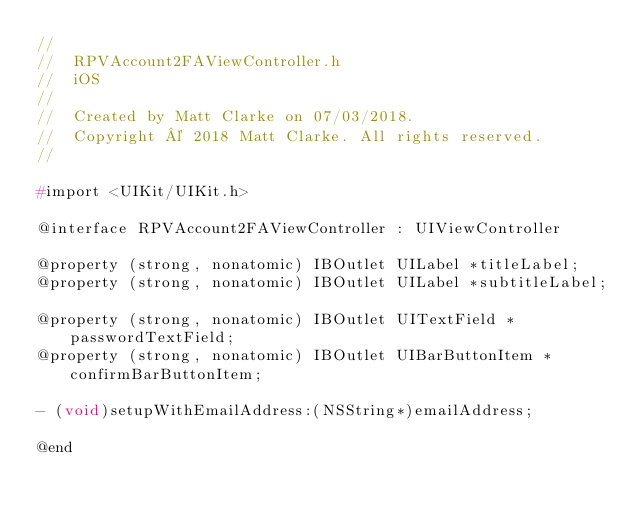<code> <loc_0><loc_0><loc_500><loc_500><_C_>//
//  RPVAccount2FAViewController.h
//  iOS
//
//  Created by Matt Clarke on 07/03/2018.
//  Copyright © 2018 Matt Clarke. All rights reserved.
//

#import <UIKit/UIKit.h>

@interface RPVAccount2FAViewController : UIViewController

@property (strong, nonatomic) IBOutlet UILabel *titleLabel;
@property (strong, nonatomic) IBOutlet UILabel *subtitleLabel;

@property (strong, nonatomic) IBOutlet UITextField *passwordTextField;
@property (strong, nonatomic) IBOutlet UIBarButtonItem *confirmBarButtonItem;

- (void)setupWithEmailAddress:(NSString*)emailAddress;

@end
</code> 